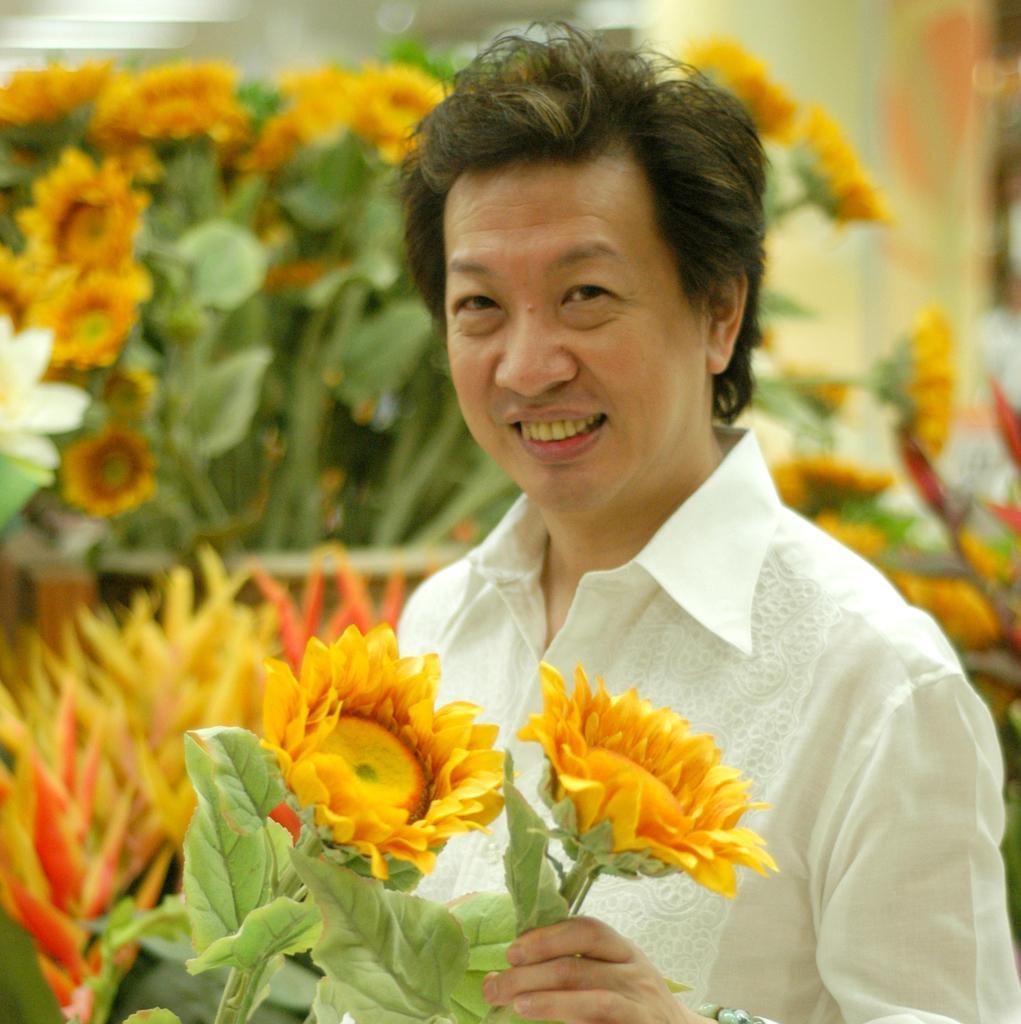How would you summarize this image in a sentence or two? In the image there is a man with white shirt is standing and he is smiling. And he is holding the yellow flowers with leaves. Behind him there are many yellow flowers with leaves. 